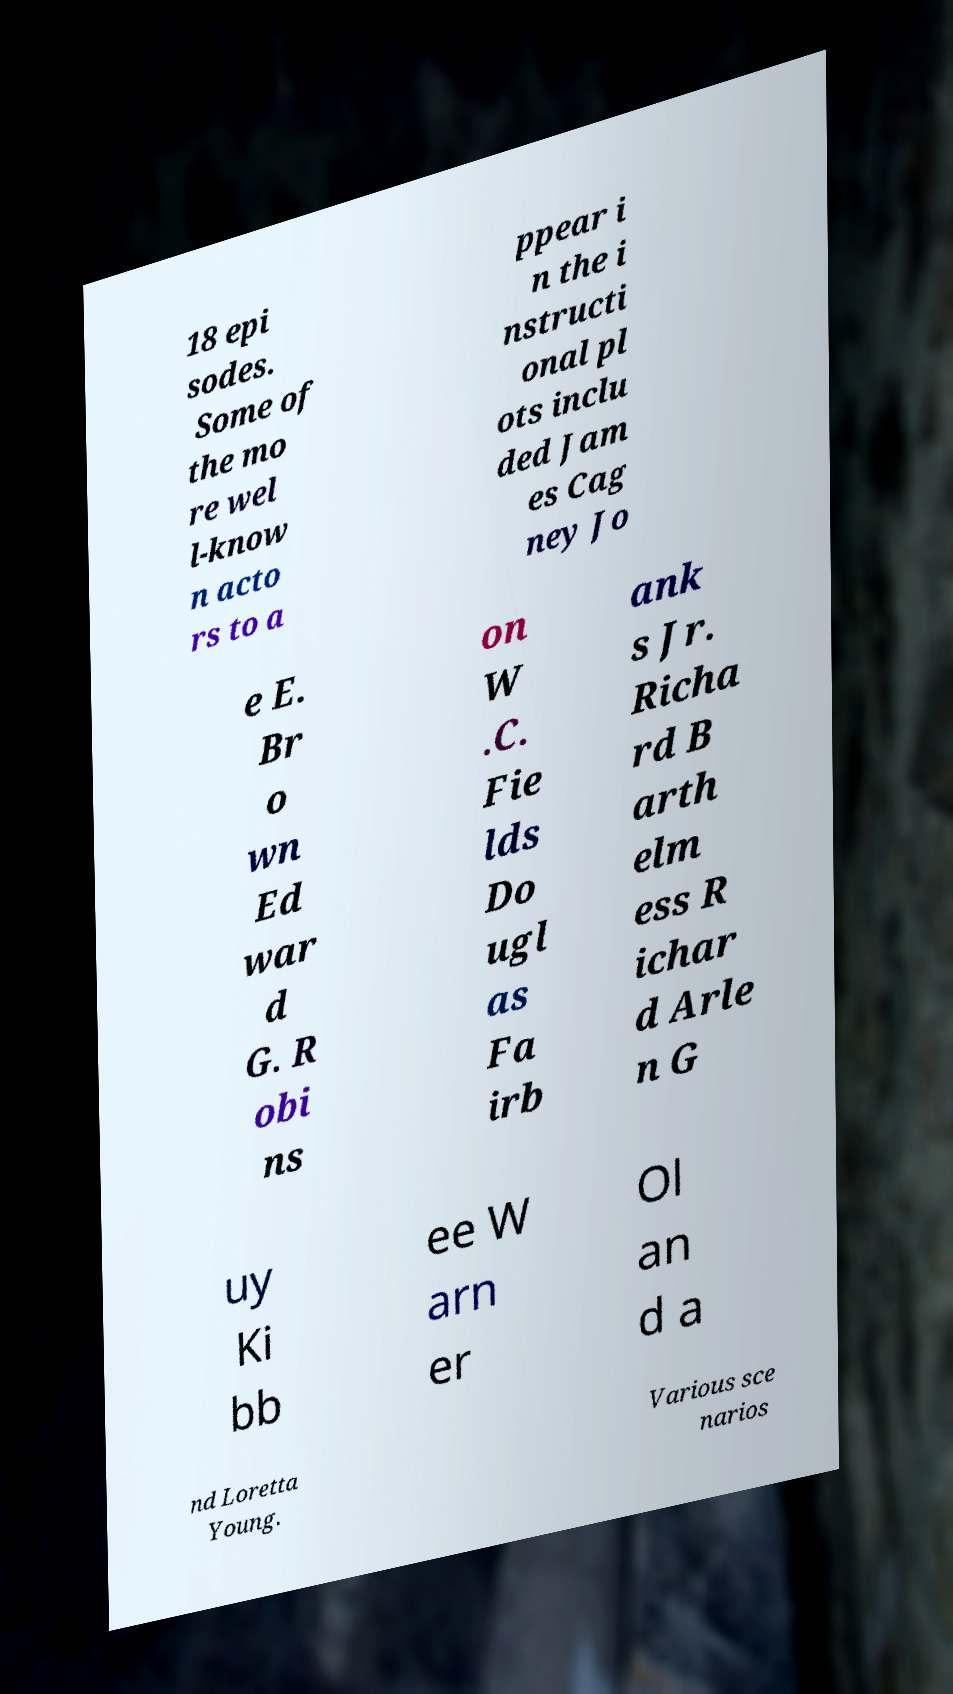Could you assist in decoding the text presented in this image and type it out clearly? 18 epi sodes. Some of the mo re wel l-know n acto rs to a ppear i n the i nstructi onal pl ots inclu ded Jam es Cag ney Jo e E. Br o wn Ed war d G. R obi ns on W .C. Fie lds Do ugl as Fa irb ank s Jr. Richa rd B arth elm ess R ichar d Arle n G uy Ki bb ee W arn er Ol an d a nd Loretta Young. Various sce narios 